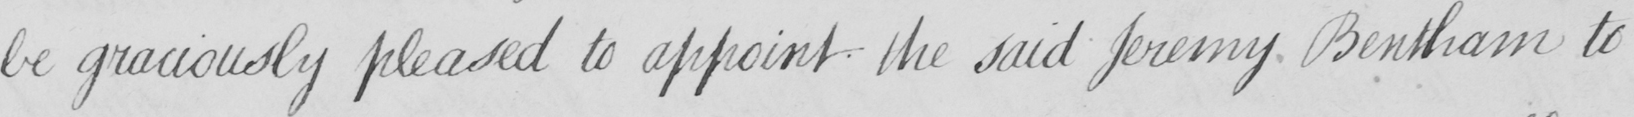Can you read and transcribe this handwriting? be graciously pleased to appoint the said Jeremy Bentham to 